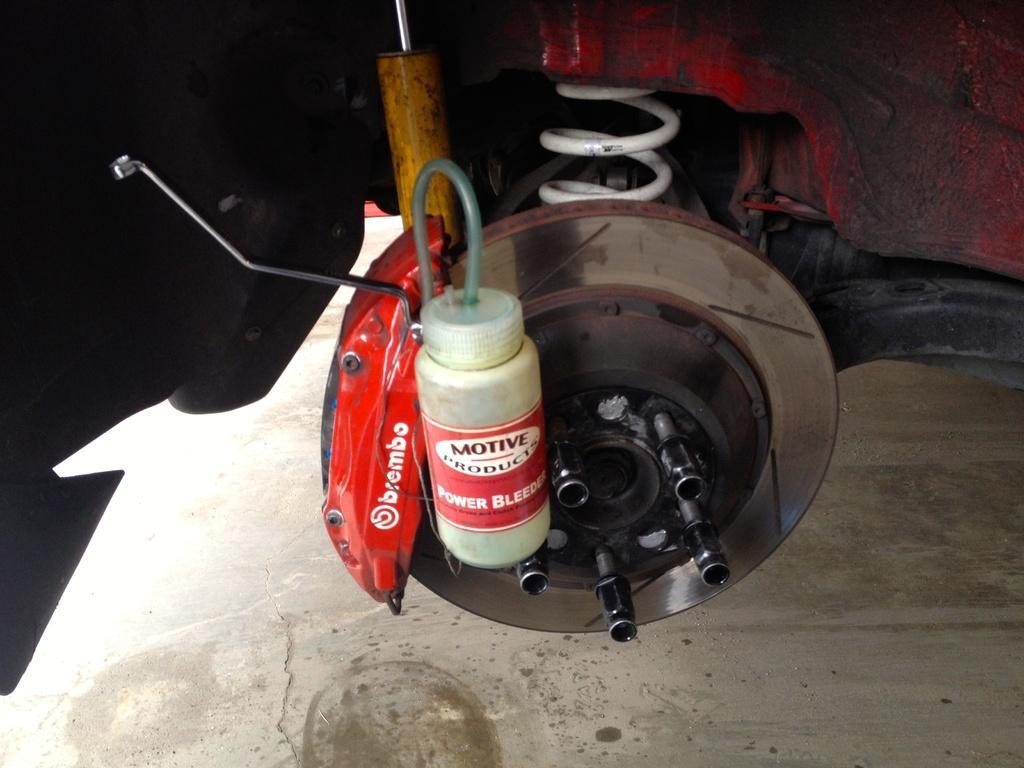Please provide a concise description of this image. In this image we can see a bottle is attached to the wheel alloy and here we can see the spring and here we can see the ground. 